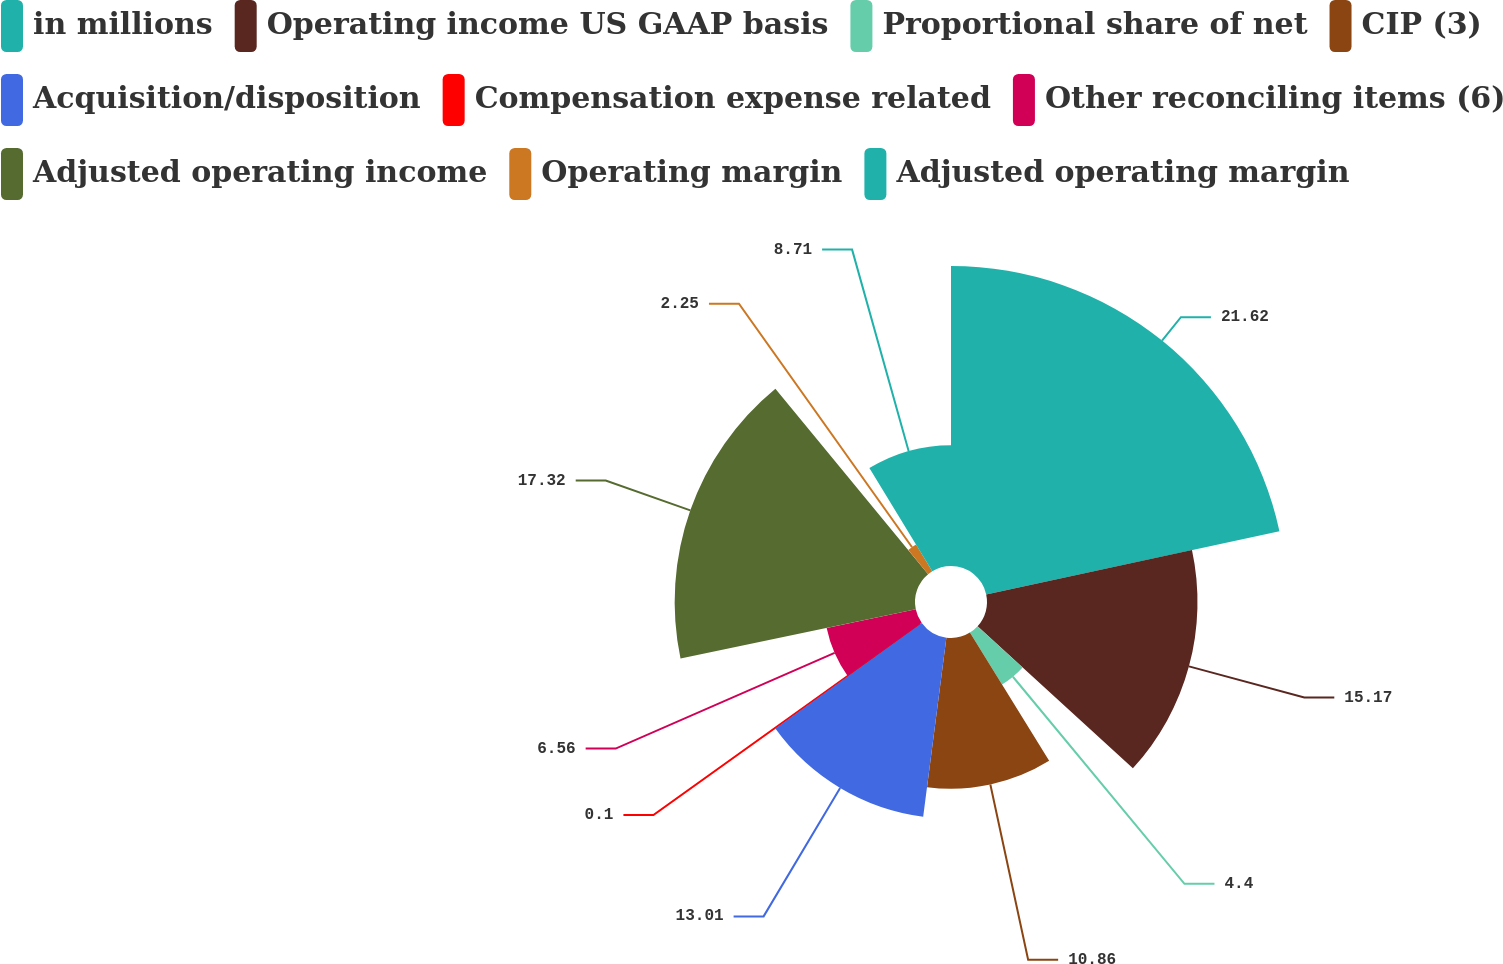Convert chart to OTSL. <chart><loc_0><loc_0><loc_500><loc_500><pie_chart><fcel>in millions<fcel>Operating income US GAAP basis<fcel>Proportional share of net<fcel>CIP (3)<fcel>Acquisition/disposition<fcel>Compensation expense related<fcel>Other reconciling items (6)<fcel>Adjusted operating income<fcel>Operating margin<fcel>Adjusted operating margin<nl><fcel>21.62%<fcel>15.17%<fcel>4.4%<fcel>10.86%<fcel>13.01%<fcel>0.1%<fcel>6.56%<fcel>17.32%<fcel>2.25%<fcel>8.71%<nl></chart> 